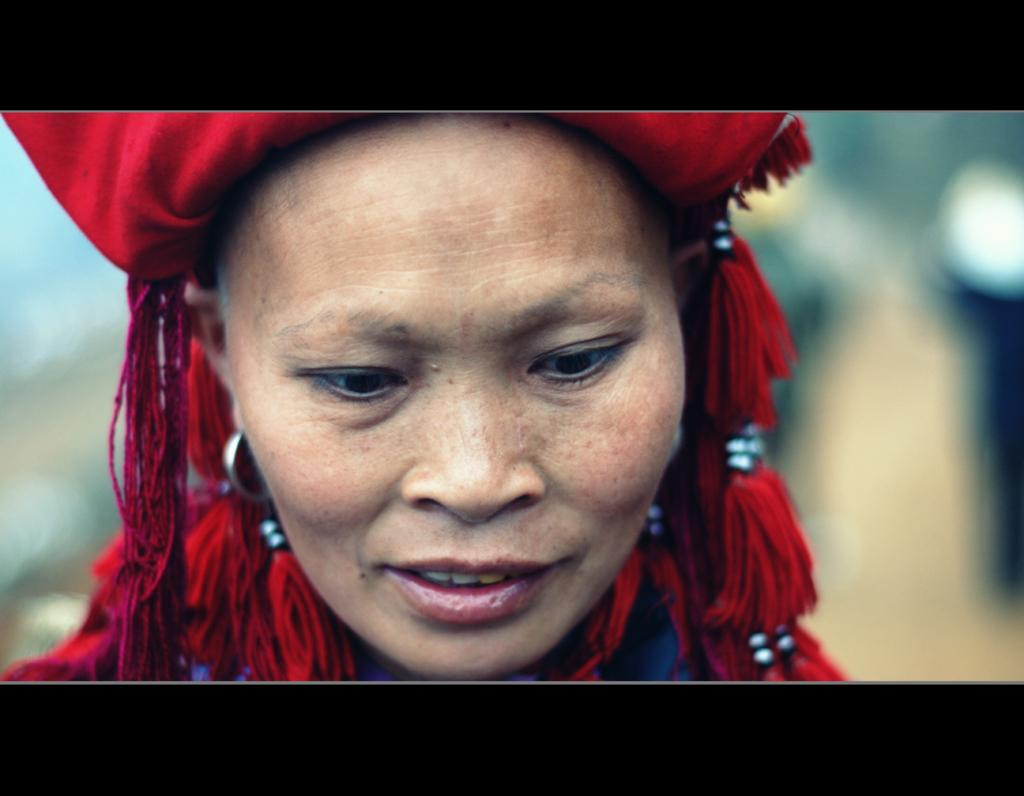What is the main subject of the image? The main subject of the image is a woman. What is the woman wearing on her head? The woman is wearing a red cap. What type of coat is the mother wearing in the image? There is no mention of a mother or a coat in the image; it only features a woman wearing a red cap. 